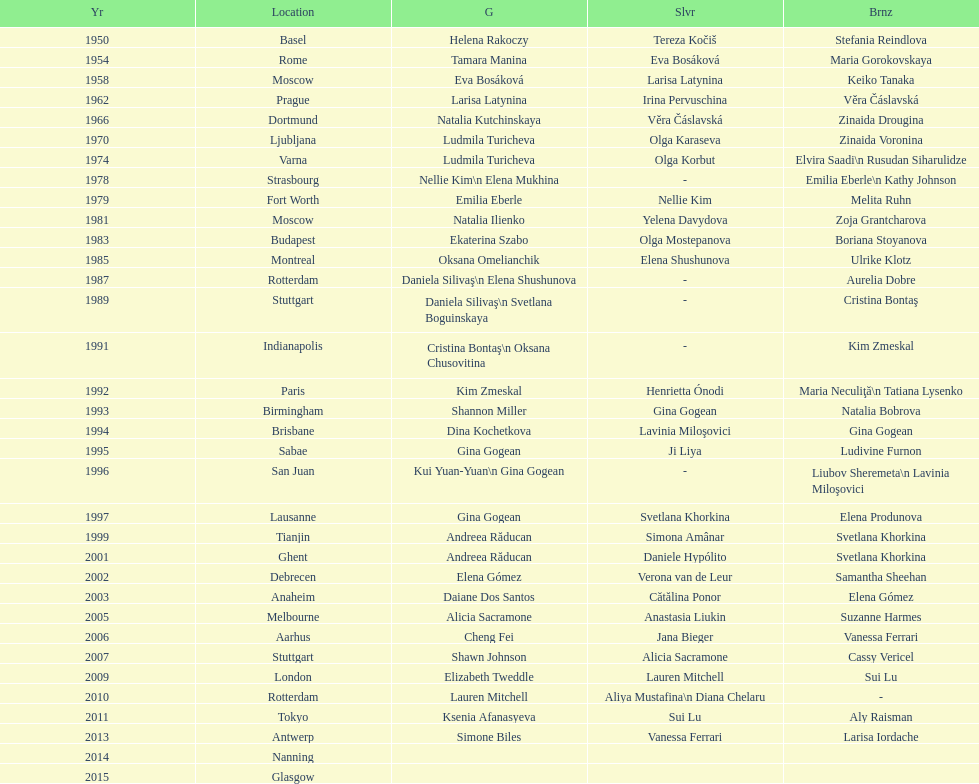Where did the world artistic gymnastics take place before san juan? Sabae. 